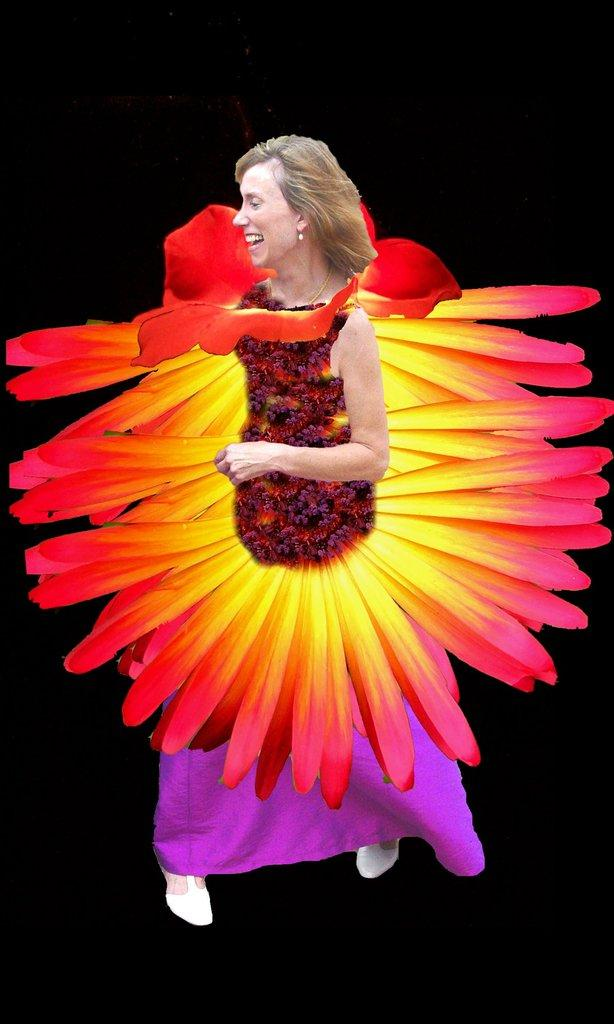Who or what is the main subject of the image? There is a person in the image. What is the person wearing? The person is wearing a costume with different colors. What is the color of the background in the image? The background of the image is black. Can you tell if the image has been altered or edited in any way? Yes, the image appears to be edited. What is the person's income in the image? There is no information about the person's income in the image. How many letters are visible in the image? There is no mention of letters in the image, so we cannot determine how many are visible. 